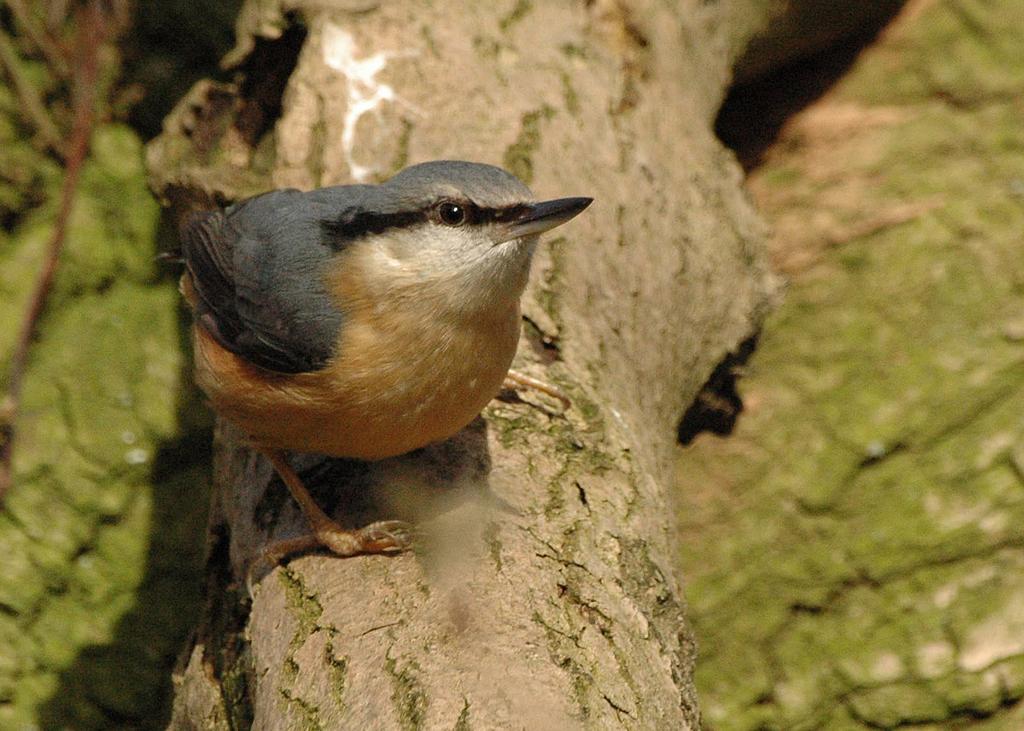Describe this image in one or two sentences. In this image we can see a bird on the bark of a tree. 